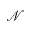Convert formula to latex. <formula><loc_0><loc_0><loc_500><loc_500>\mathcal { N }</formula> 